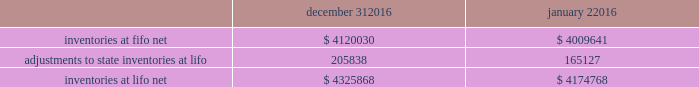Advance auto parts , inc .
And subsidiaries notes to the consolidated financial statements december 31 , 2016 , january 2 , 2016 and january 3 , 2015 ( in thousands , except per share data ) 2 .
Inventories , net : merchandise inventory the company used the lifo method of accounting for approximately 89% ( 89 % ) of inventories at both december 31 , 2016 and january 2 , 2016 .
Under lifo , the company 2019s cost of sales reflects the costs of the most recently purchased inventories , while the inventory carrying balance represents the costs for inventories purchased in 2016 and prior years .
As a result of utilizing lifo , the company recorded a reduction to cost of sales of $ 40711 and $ 42295 in 2016 and 2015 , respectively , and an increase to cost of sales of $ 8930 in 2014 .
Historically , the company 2019s overall costs to acquire inventory for the same or similar products have generally decreased as the company has been able to leverage its continued growth and execution of merchandise strategies .
The increase in cost of sales for 2014 was the result of an increase in supply chain costs .
Product cores the remaining inventories are comprised of product cores , the non-consumable portion of certain parts and batteries and the inventory of certain subsidiaries , which are valued under the first-in , first-out ( 201cfifo 201d ) method .
Product cores are included as part of the company 2019s merchandise costs and are either passed on to the customer or returned to the vendor .
Because product cores are not subject to frequent cost changes like the company 2019s other merchandise inventory , there is no material difference when applying either the lifo or fifo valuation method .
Inventory overhead costs purchasing and warehousing costs included in inventory as of december 31 , 2016 and january 2 , 2016 , were $ 395240 and $ 359829 , respectively .
Inventory balance and inventory reserves inventory balances at the end of 2016 and 2015 were as follows : december 31 , january 2 .
Inventory quantities are tracked through a perpetual inventory system .
The company completes physical inventories and other targeted inventory counts in its store locations to ensure the accuracy of the perpetual inventory quantities of merchandise and core inventory .
In its distribution centers and branches , the company uses a cycle counting program to ensure the accuracy of the perpetual inventory quantities of merchandise and product core inventory .
Reserves for estimated shrink are established based on the results of physical inventories conducted by the company and other targeted inventory counts in its stores , results from recent cycle counts in its distribution facilities and historical and current loss trends .
The company also establishes reserves for potentially excess and obsolete inventories based on ( i ) current inventory levels , ( ii ) the historical analysis of product sales and ( iii ) current market conditions .
The company has return rights with many of its vendors and the majority of excess inventory is returned to its vendors for full credit .
In certain situations , the company establishes reserves when less than full credit is expected from a vendor or when liquidating product will result in retail prices below recorded costs. .
What percent increase was the adjustments to state inventories of the 2016 starting inventories? 
Rationale: to find the increase in inventories one must divide the amount that is adding to the inventories by total original amount of inventories .
Computations: (205838 / 4120030)
Answer: 0.04996. 